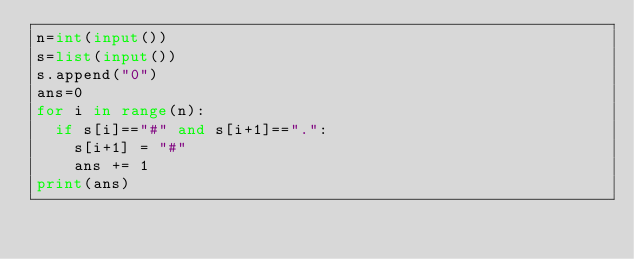<code> <loc_0><loc_0><loc_500><loc_500><_Python_>n=int(input())
s=list(input())
s.append("0")
ans=0
for i in range(n):
  if s[i]=="#" and s[i+1]==".":
    s[i+1] = "#"
    ans += 1
print(ans)</code> 